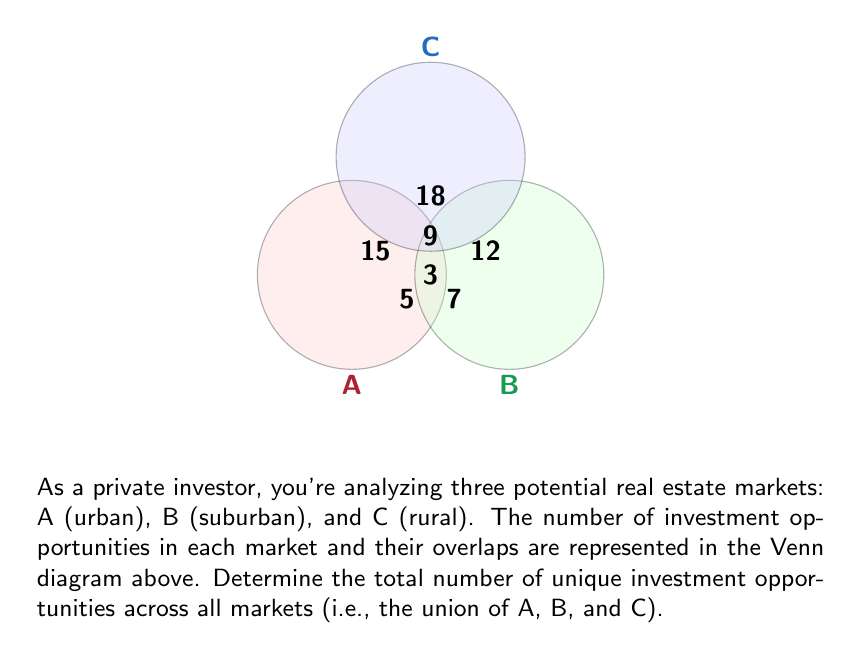Help me with this question. To find the union of the three sets A, B, and C, we need to add up all unique elements. Let's approach this step-by-step:

1) First, let's identify the elements in each region:
   - Exclusive to A: 15
   - Exclusive to B: 12
   - Exclusive to C: 18
   - Shared by A and B only: 5
   - Shared by B and C only: 7
   - Shared by A and C only: 9
   - Shared by all three (A ∩ B ∩ C): 3

2) The union of sets A, B, and C is represented mathematically as:

   $$|A ∪ B ∪ C| = |A| + |B| + |C| - |A ∩ B| - |B ∩ C| - |A ∩ C| + |A ∩ B ∩ C|$$

3) Let's calculate each term:
   - $|A| = 15 + 5 + 9 + 3 = 32$
   - $|B| = 12 + 5 + 7 + 3 = 27$
   - $|C| = 18 + 9 + 7 + 3 = 37$
   - $|A ∩ B| = 5 + 3 = 8$
   - $|B ∩ C| = 7 + 3 = 10$
   - $|A ∩ C| = 9 + 3 = 12$
   - $|A ∩ B ∩ C| = 3$

4) Now, let's substitute these values into our equation:

   $$|A ∪ B ∪ C| = 32 + 27 + 37 - 8 - 10 - 12 + 3 = 69$$

Therefore, the total number of unique investment opportunities across all markets is 69.
Answer: 69 